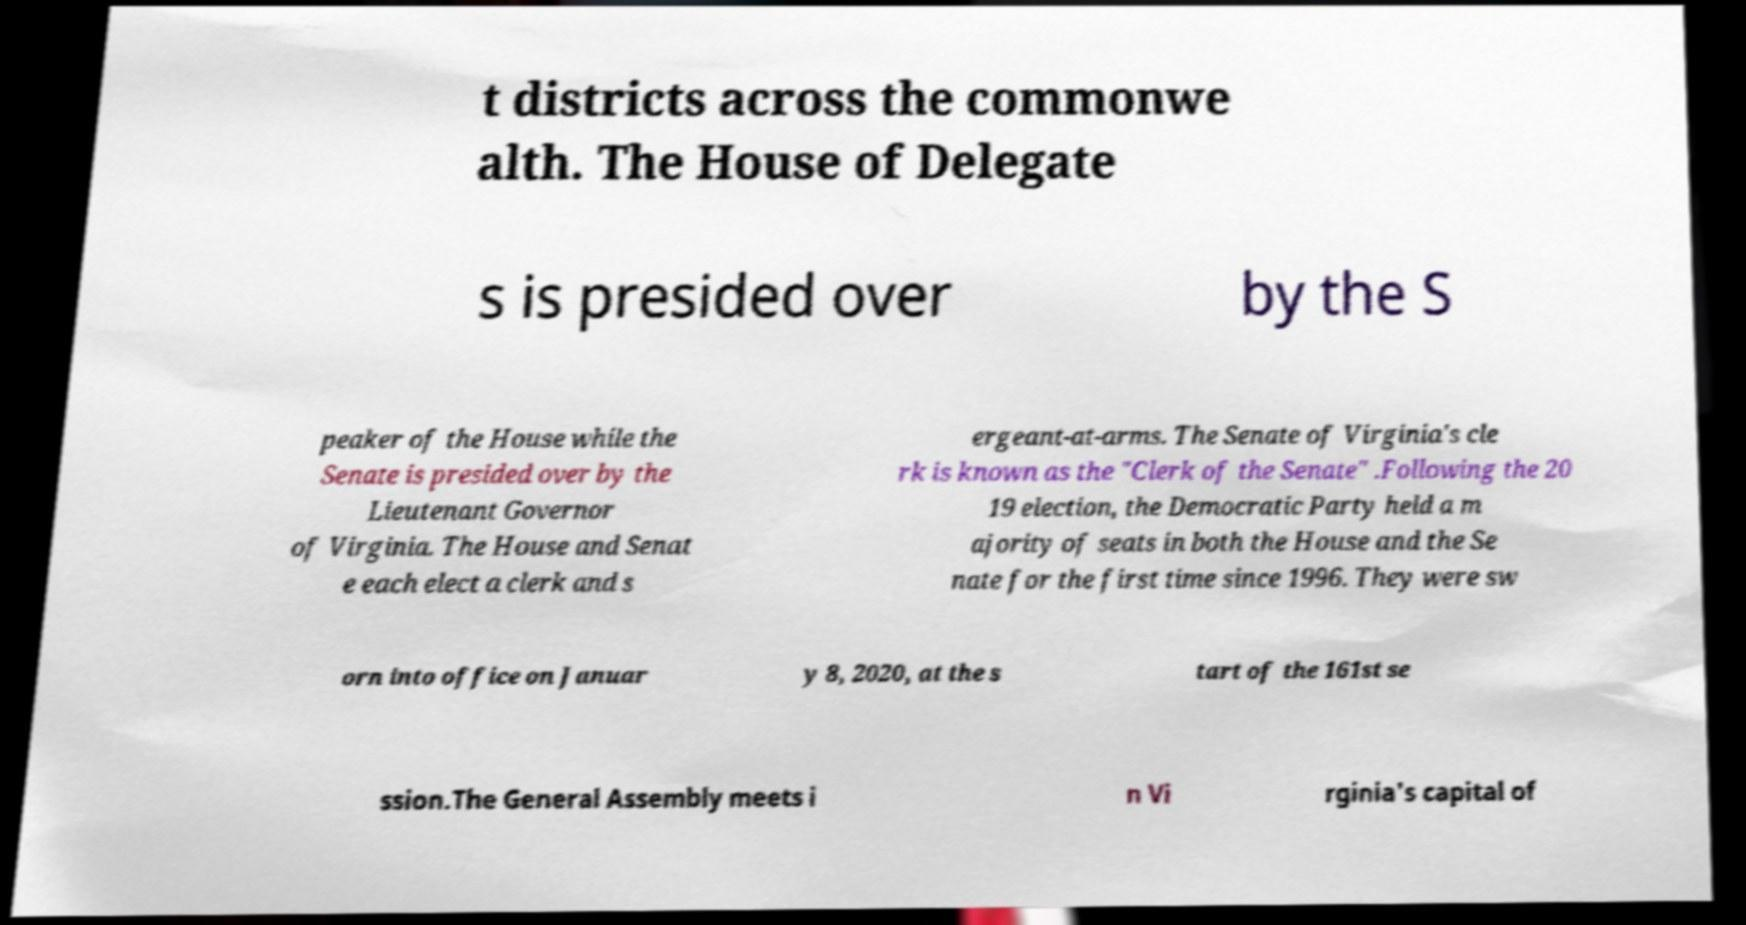Could you assist in decoding the text presented in this image and type it out clearly? t districts across the commonwe alth. The House of Delegate s is presided over by the S peaker of the House while the Senate is presided over by the Lieutenant Governor of Virginia. The House and Senat e each elect a clerk and s ergeant-at-arms. The Senate of Virginia's cle rk is known as the "Clerk of the Senate" .Following the 20 19 election, the Democratic Party held a m ajority of seats in both the House and the Se nate for the first time since 1996. They were sw orn into office on Januar y 8, 2020, at the s tart of the 161st se ssion.The General Assembly meets i n Vi rginia's capital of 